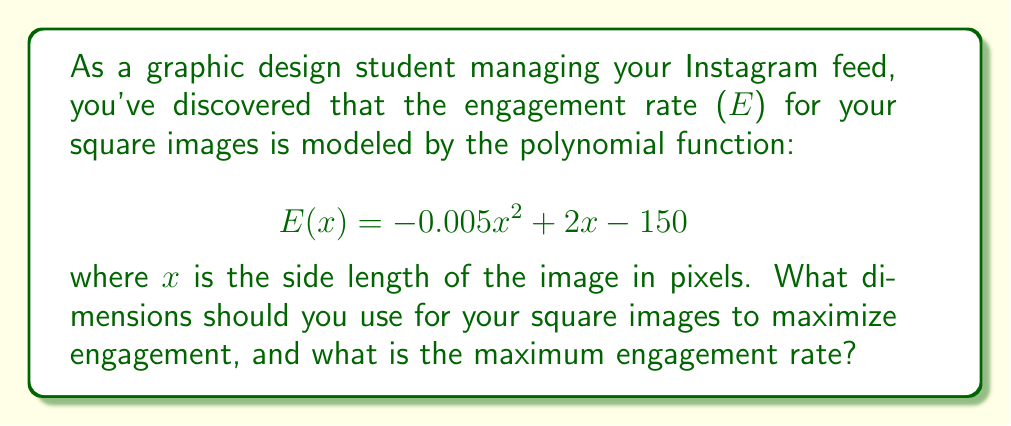Can you solve this math problem? To find the dimensions that maximize engagement, we need to find the vertex of the parabola represented by the given quadratic function. The steps are as follows:

1. The quadratic function is in the form $ax^2 + bx + c$, where:
   $a = -0.005$
   $b = 2$
   $c = -150$

2. For a quadratic function, the x-coordinate of the vertex is given by $x = -\frac{b}{2a}$:

   $$x = -\frac{2}{2(-0.005)} = -\frac{2}{-0.01} = 200$$

3. This means the optimal side length for the square image is 200 pixels.

4. To find the maximum engagement rate, we substitute x = 200 into the original function:

   $$E(200) = -0.005(200)^2 + 2(200) - 150$$
   $$= -0.005(40000) + 400 - 150$$
   $$= -200 + 400 - 150$$
   $$= 50$$

Therefore, the maximum engagement rate is 50.
Answer: 200 x 200 pixels; 50 